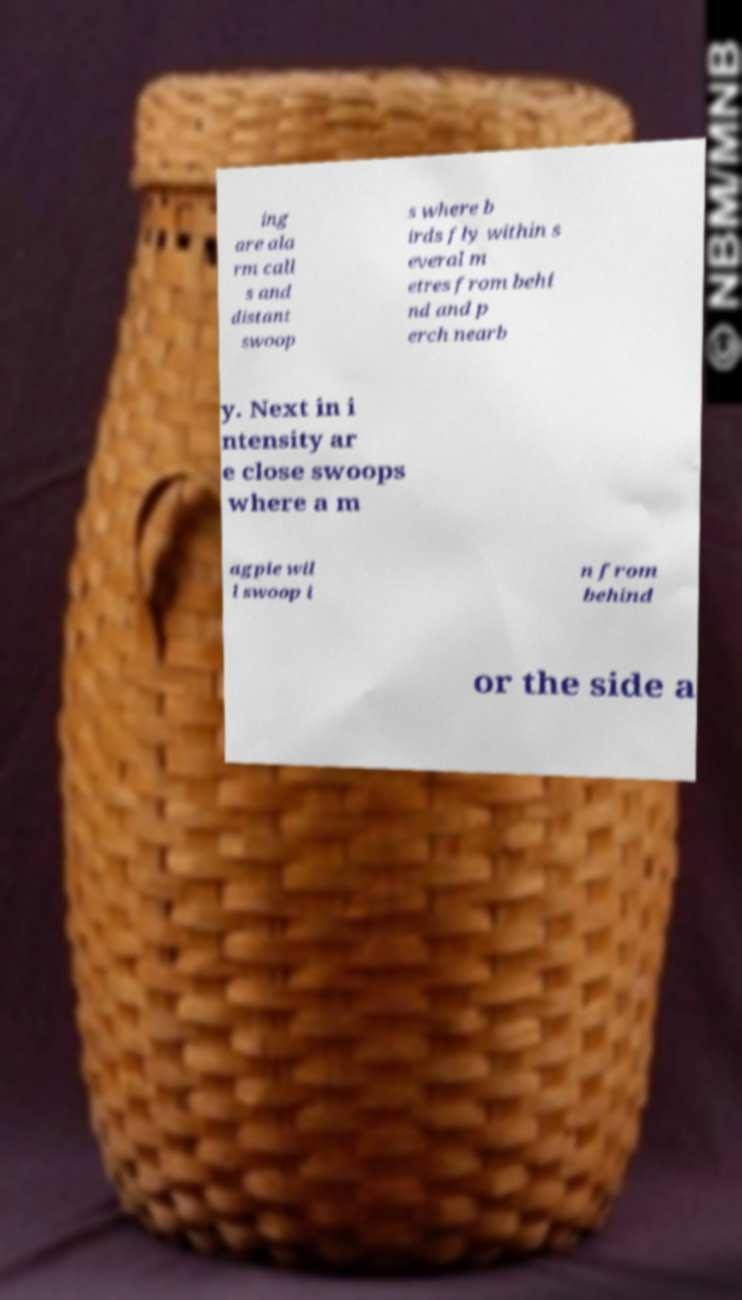Please read and relay the text visible in this image. What does it say? ing are ala rm call s and distant swoop s where b irds fly within s everal m etres from behi nd and p erch nearb y. Next in i ntensity ar e close swoops where a m agpie wil l swoop i n from behind or the side a 